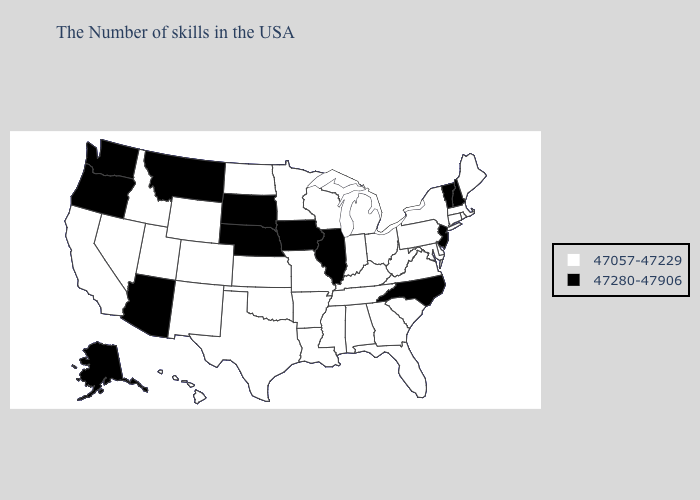What is the value of Iowa?
Short answer required. 47280-47906. Which states have the lowest value in the USA?
Keep it brief. Maine, Massachusetts, Rhode Island, Connecticut, New York, Delaware, Maryland, Pennsylvania, Virginia, South Carolina, West Virginia, Ohio, Florida, Georgia, Michigan, Kentucky, Indiana, Alabama, Tennessee, Wisconsin, Mississippi, Louisiana, Missouri, Arkansas, Minnesota, Kansas, Oklahoma, Texas, North Dakota, Wyoming, Colorado, New Mexico, Utah, Idaho, Nevada, California, Hawaii. Does Wisconsin have the highest value in the USA?
Keep it brief. No. Among the states that border Utah , does Arizona have the lowest value?
Keep it brief. No. What is the value of Virginia?
Write a very short answer. 47057-47229. What is the lowest value in the West?
Be succinct. 47057-47229. Which states have the highest value in the USA?
Answer briefly. New Hampshire, Vermont, New Jersey, North Carolina, Illinois, Iowa, Nebraska, South Dakota, Montana, Arizona, Washington, Oregon, Alaska. Does the first symbol in the legend represent the smallest category?
Answer briefly. Yes. What is the highest value in states that border West Virginia?
Give a very brief answer. 47057-47229. Name the states that have a value in the range 47057-47229?
Write a very short answer. Maine, Massachusetts, Rhode Island, Connecticut, New York, Delaware, Maryland, Pennsylvania, Virginia, South Carolina, West Virginia, Ohio, Florida, Georgia, Michigan, Kentucky, Indiana, Alabama, Tennessee, Wisconsin, Mississippi, Louisiana, Missouri, Arkansas, Minnesota, Kansas, Oklahoma, Texas, North Dakota, Wyoming, Colorado, New Mexico, Utah, Idaho, Nevada, California, Hawaii. Name the states that have a value in the range 47280-47906?
Quick response, please. New Hampshire, Vermont, New Jersey, North Carolina, Illinois, Iowa, Nebraska, South Dakota, Montana, Arizona, Washington, Oregon, Alaska. What is the value of Wisconsin?
Be succinct. 47057-47229. What is the highest value in the Northeast ?
Write a very short answer. 47280-47906. What is the highest value in the USA?
Quick response, please. 47280-47906. What is the value of North Carolina?
Quick response, please. 47280-47906. 